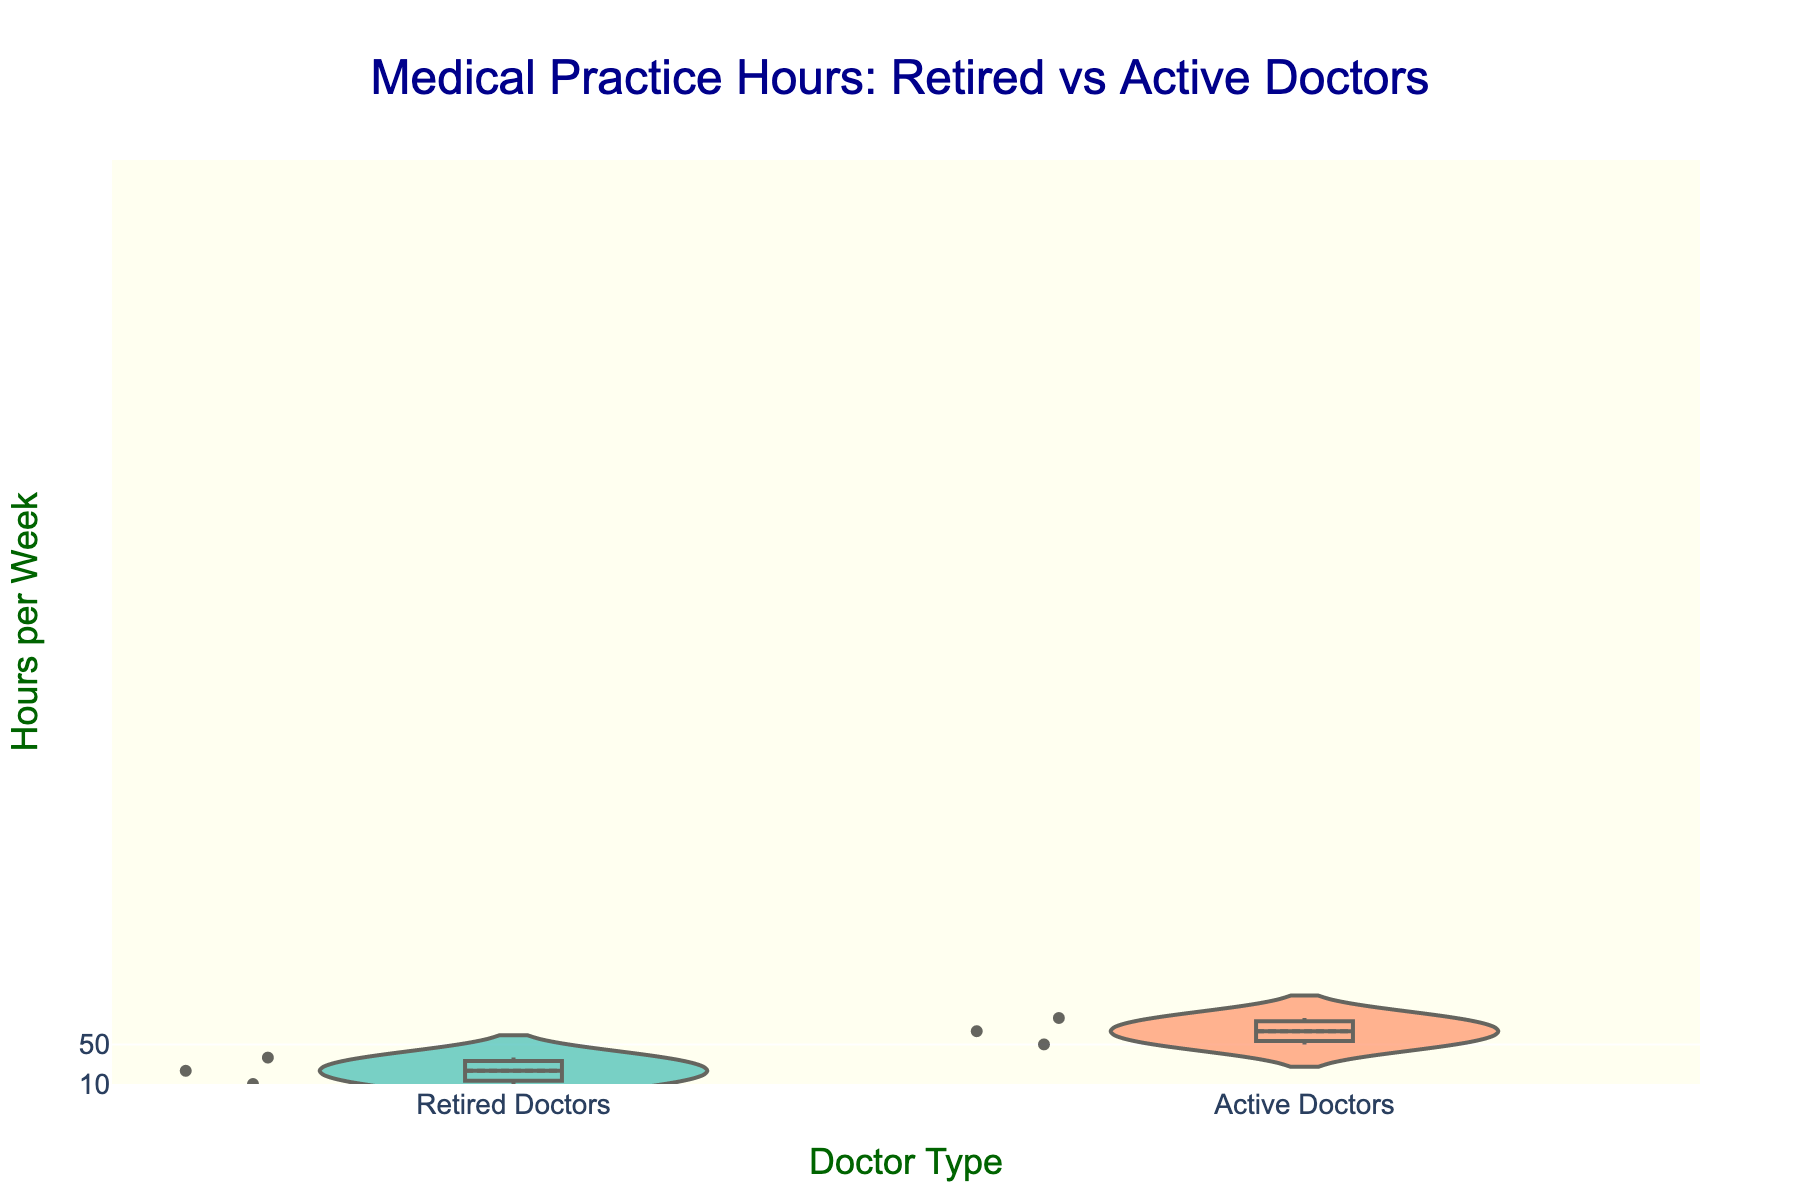What is the title of the figure? The title is located at the top of the figure. It reads: "Medical Practice Hours: Retired vs Active Doctors".
Answer: Medical Practice Hours: Retired vs Active Doctors Which doctor type has the higher mean practice hours? Compare the positions of the mean lines (visible through a darker central point) within the violins; the mean line for Active Doctors is higher than that of Retired Doctors.
Answer: Active Doctors How many hours is the median practice time for Retired Doctors? Look for the median line (the middle line in the box plot) within the violin plot for Retired Doctors. It appears to be around 10 hours.
Answer: 10 hours What is the range of practice hours for Active Doctors? The range is determined by the spread from the bottom to the top of the violin plot for Active Doctors. It ranges from around 50 to 60 hours per week.
Answer: 50 to 60 hours Which group shows more variability in their practice hours, Retired Doctors or Active Doctors? Observe the spread of the violin plots: the violin for Active Doctors is narrower compared to that for Retired Doctors, indicating less variability.
Answer: Retired Doctors What is the most common practice hour for Retired Doctors? The most common (or mode) practice hour value can be visually estimated by the thickness and concentration in the center of the violin plot for Retired Doctors, which is around 10 hours.
Answer: 10 hours Comparing the upper quartile for both groups, which one has a higher value? The upper quartile (top of the box within the violin) for Active Doctors appears higher than that for Retired Doctors.
Answer: Active Doctors Is it possible for both doctor types to have the same practice hours? Since both violin plots are in the same range for values overlapping around 10 hours, yes, they can have the same practice hours, but typically Retired Doctors have fewer hours.
Answer: Yes What is the minimum value observed in the Active Doctors group? Look at the bottom of the violin plot for Active Doctors, which represents the minimum value around 50 hours.
Answer: 50 hours What is the maximum value observed for Retired Doctors? Observe the topmost point of the violin plot for Retired Doctors; it looks like the maximum value is around 12 hours.
Answer: 12 hours 